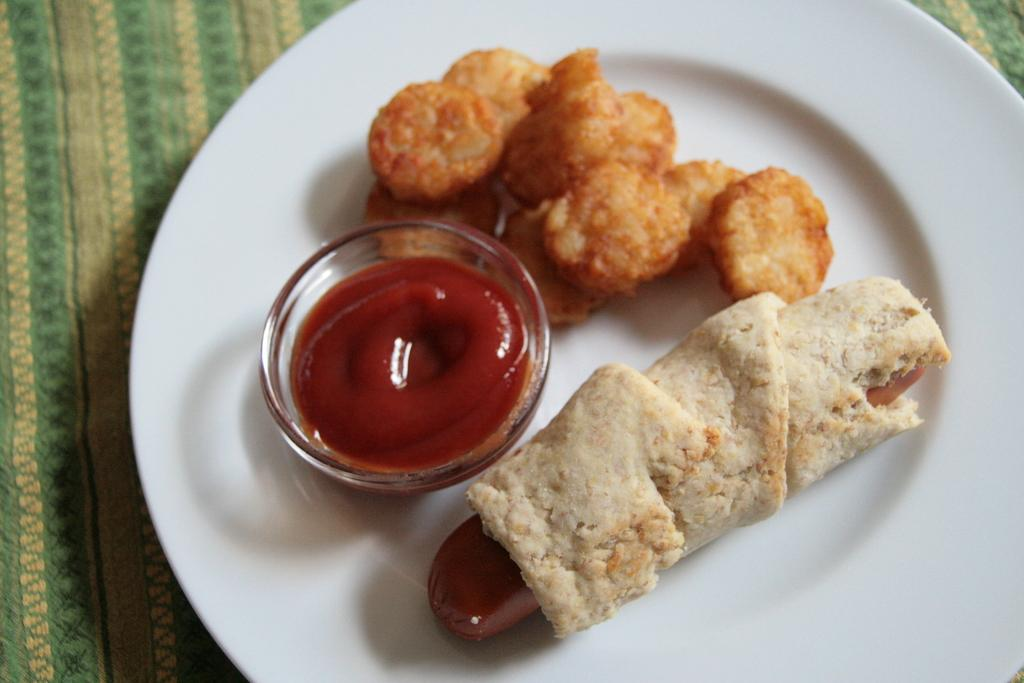What type of food is visible in the image? The food in the image has brown, red, and cream colors. How is the food arranged or presented? A: The food is on a plate. What color is the plate? The plate is white. What is the plate resting on? The plate is on a green cloth. What type of wax is being applied to the body by the doctor in the image? There is no text or image of a doctor or wax application in the image; it only features food on a plate. 